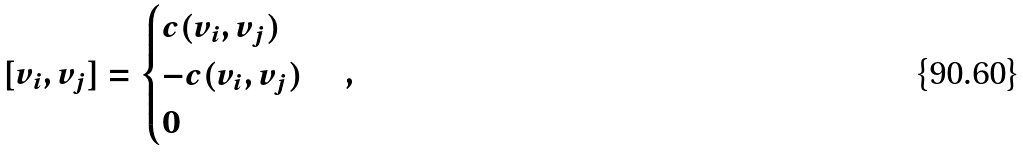Convert formula to latex. <formula><loc_0><loc_0><loc_500><loc_500>[ v _ { i } , v _ { j } ] = \begin{cases} c ( v _ { i } , v _ { j } ) & \\ - c ( v _ { i } , v _ { j } ) & \\ 0 & \\ \end{cases} ,</formula> 